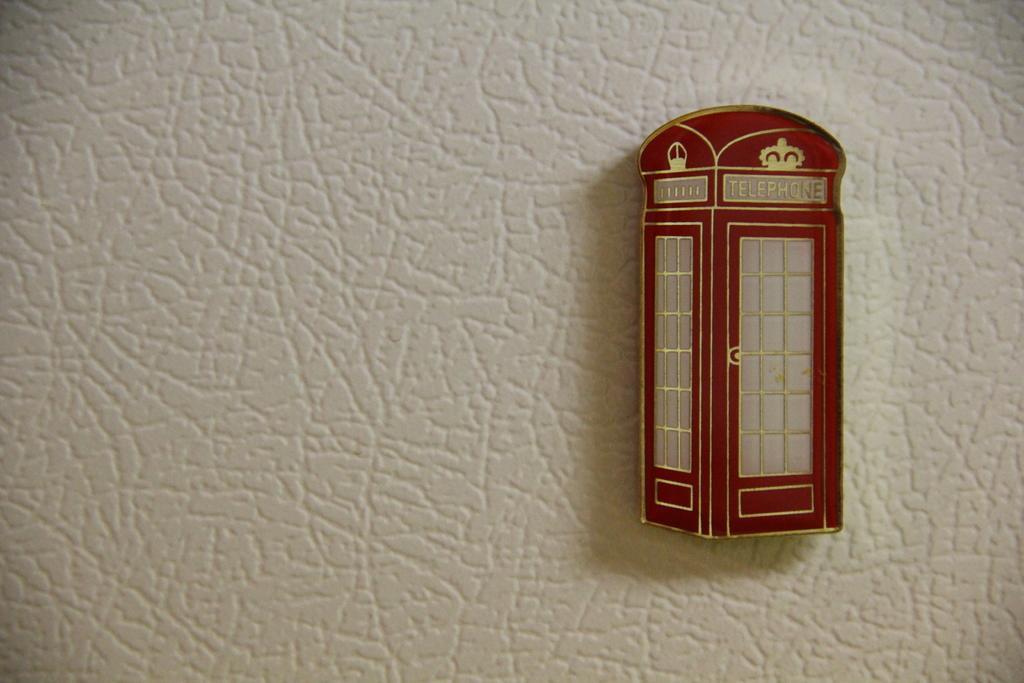How would you summarize this image in a sentence or two? This image is taken indoors. In the middle of the image there is a wall. On the right side of the image there is a telephone booth. 